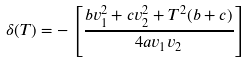<formula> <loc_0><loc_0><loc_500><loc_500>\delta ( T ) = - \left [ { \frac { b v _ { 1 } ^ { 2 } + c v _ { 2 } ^ { 2 } + T ^ { 2 } ( b + c ) } { 4 a v _ { 1 } v _ { 2 } } } \right ]</formula> 